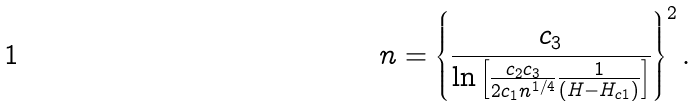<formula> <loc_0><loc_0><loc_500><loc_500>n = \left \{ \frac { c _ { 3 } } { \ln \left [ \frac { c _ { 2 } c _ { 3 } } { 2 c _ { 1 } n ^ { 1 / 4 } } \frac { 1 } { ( H - H _ { c 1 } ) } \right ] } \right \} ^ { 2 } .</formula> 